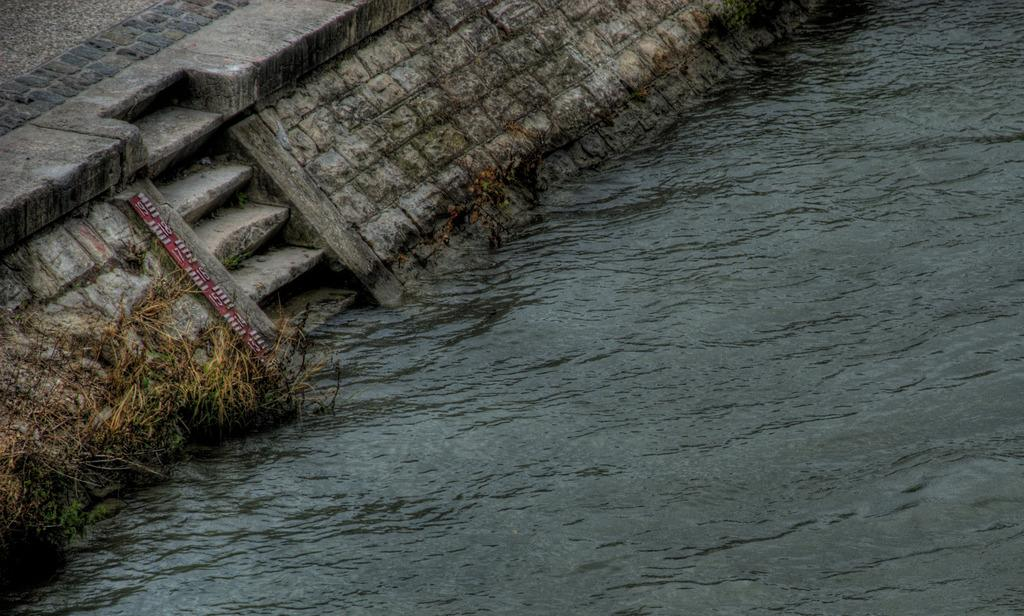What is the primary element visible in the image? There is water in the image. What type of vegetation can be seen in the image? There is brown and green grass in the image. Are there any architectural features present in the image? Yes, there are stairs in the image. What is the surface on which the water and grass are located? The ground is visible in the image. What tool is present in the image for measuring or comparing? There is a measuring scale in the image. What colors are used to design the measuring scale? The measuring scale is red and white in color. What type of operation is being performed on the water in the image? There is no operation being performed on the water in the image; it is simply visible. What type of control is being exerted over the grass in the image? There is no control being exerted over the grass in the image; it is naturally growing. 